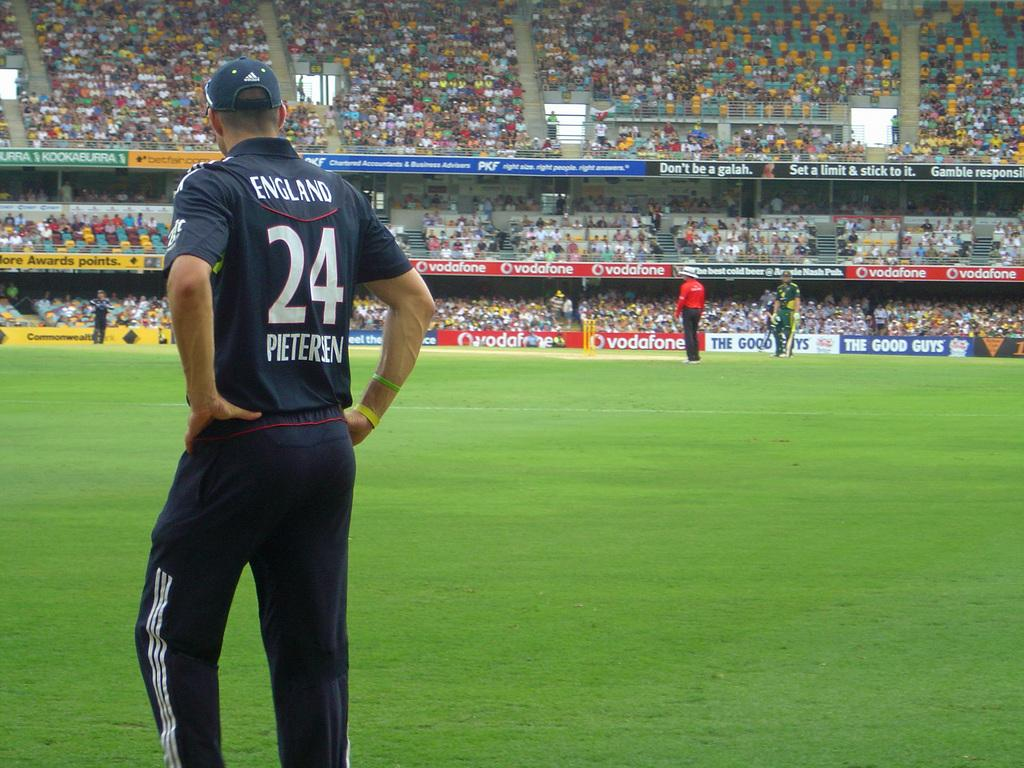<image>
Create a compact narrative representing the image presented. A man in a number 24 England shirt stands on a soccer field. 